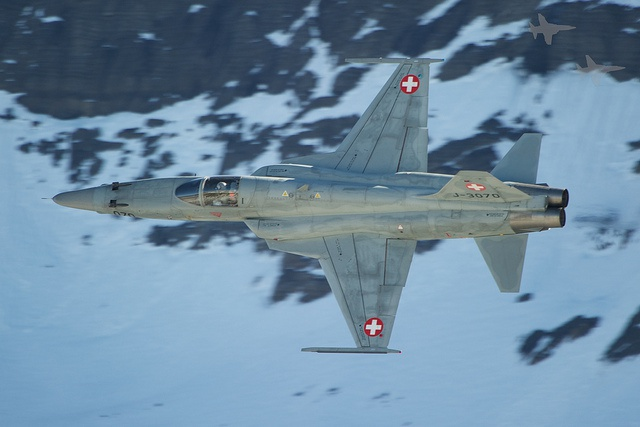Describe the objects in this image and their specific colors. I can see airplane in darkblue, gray, and darkgray tones and people in darkblue, gray, darkgray, blue, and black tones in this image. 